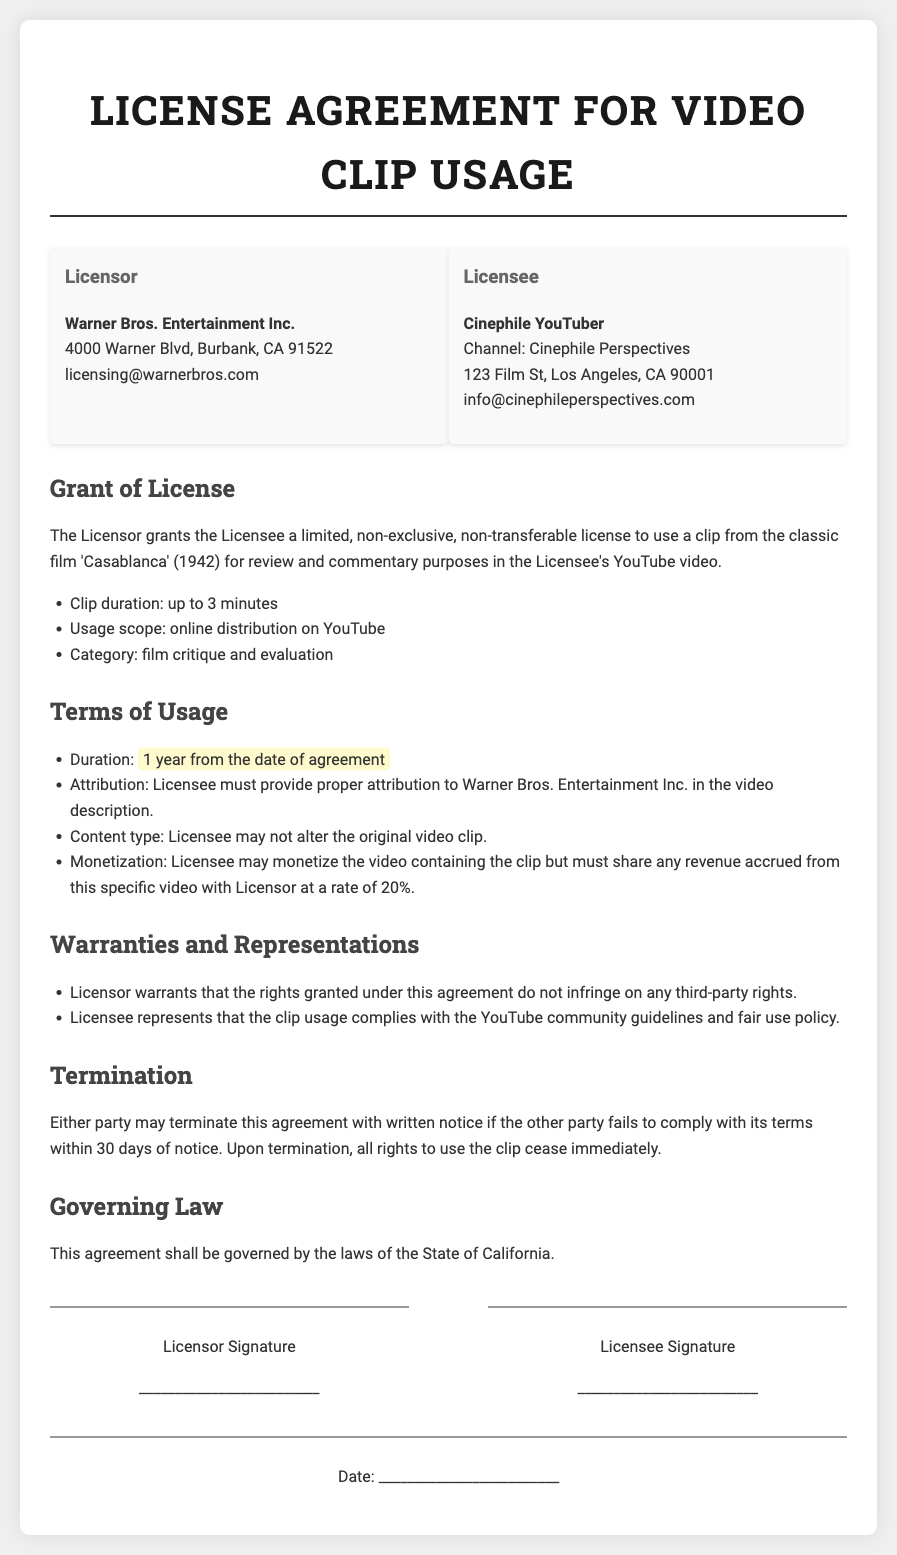what is the name of the Licensor? The name of the Licensor is mentioned at the beginning of the document under the party information section.
Answer: Warner Bros. Entertainment Inc what is the duration of the license? The duration of the license is specified in the Terms of Usage section of the document.
Answer: 1 year from the date of agreement what type of content is allowed to be used? The allowed content type is stated in the Grant of License and Terms of Usage sections.
Answer: a clip from the classic film 'Casablanca' (1942) how much revenue must the Licensee share with the Licensor? The revenue share percentage is mentioned under the Terms of Usage, specifically regarding monetization.
Answer: 20% what must the Licensee provide in the video description? The requirement for the video description is specified in the Terms of Usage section.
Answer: proper attribution to Warner Bros. Entertainment Inc what is the termination notice period? The notice period for termination is described in the Termination section concerning compliance with terms.
Answer: 30 days under which state's laws is the agreement governed? The governing law for the agreement is outlined in the Governing Law section.
Answer: the State of California what is the scope of usage stated in the document? The usage scope paragraph specifies how the clip can be distributed.
Answer: online distribution on YouTube what is the maximum clip duration allowed? The maximum duration for the clip is mentioned in the Grant of License.
Answer: up to 3 minutes 